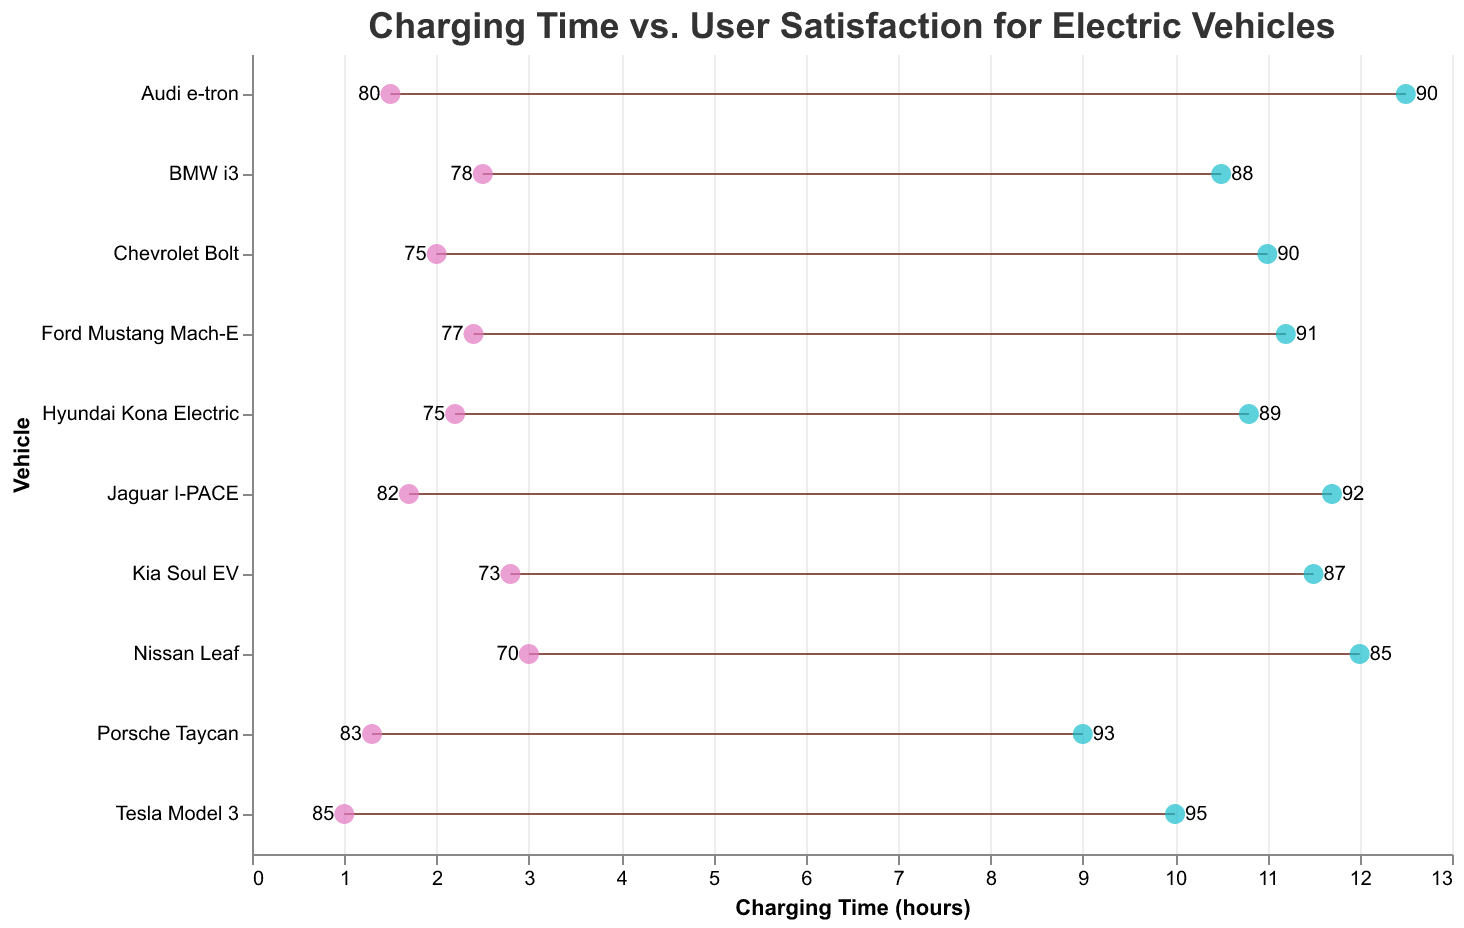What is the minimum charging time for the Tesla Model 3? The Tesla Model 3 has a minimum charging time indicated by the leftmost point of the dumbbell plot for that vehicle.
Answer: 1 hour Which vehicle has the highest maximum user satisfaction rating? The maximum user satisfaction rating is indicated by the number on the rightmost side of each dumbbell plot. The Tesla Model 3 has a maximum rating of 95, which is higher than any other vehicle.
Answer: Tesla Model 3 What is the average maximum charging time across all vehicles? To find the average maximum charging time, add up all the maximum charging times for each vehicle: (10 + 12 + 11 + 10.5 + 12.5 + 11.7 + 10.8 + 11.5 + 9 + 11.2) = 110.2. Then, divide by the number of vehicles (10): 110.2 / 10 = 11.02.
Answer: 11.02 hours Which vehicle shows the smallest range in charging time? The range in charging time is the difference between the maximum and minimum charging times for each vehicle. Tesla Model 3: 10 - 1 = 9, Nissan Leaf: 12 - 3 = 9, Chevrolet Bolt: 11 - 2 = 9, BMW i3: 10.5 - 2.5 = 8, Audi e-tron: 12.5 - 1.5 = 11, Jaguar I-PACE: 11.7 - 1.7 = 10, Hyundai Kona Electric: 10.8 - 2.2 = 8.6, Kia Soul EV: 11.5 - 2.8 = 8.7, Porsche Taycan: 9 - 1.3 = 7.7, Ford Mustang Mach-E: 11.2 - 2.4 = 8.8. Therefore, Porsche Taycan shows the smallest range of 7.7 hours.
Answer: Porsche Taycan For which vehicle is the user satisfaction rating range the largest? The range in user satisfaction rating is the difference between maximum and minimum user satisfaction ratings. Tesla Model 3: 95 - 85 = 10, Nissan Leaf: 85 - 70 = 15, Chevrolet Bolt: 90 - 75 = 15, BMW i3: 88 - 78 = 10, Audi e-tron: 90 - 80 = 10, Jaguar I-PACE: 92 - 82 = 10, Hyundai Kona Electric: 89 - 75 = 14, Kia Soul EV: 87 - 73 = 14, Porsche Taycan: 93 - 83 = 10, Ford Mustang Mach-E: 91 - 77 = 14. Therefore, Chevrolet Bolt and Nissan Leaf have the largest user satisfaction rating range of 15.
Answer: Chevrolet Bolt and Nissan Leaf Which vehicle has the shortest maximum charging time and what is it? The shortest maximum charging time is indicated by the rightmost points of the dumbbell plots. The Porsche Taycan has the shortest maximum charging time of 9 hours.
Answer: Porsche Taycan with 9 hours What is the difference in minimum charging time between the Jaguar I-PACE and the Audi e-tron? The minimum charging time for the Jaguar I-PACE is 1.7 hours and for the Audi e-tron is 1.5 hours. The difference is 1.7 - 1.5 = 0.2 hours.
Answer: 0.2 hours Which vehicle has the highest minimum user satisfaction rating and what is it? The highest minimum user satisfaction rating is indicated by the number on the leftmost side of each vehicle’s dumbbell plot. The Tesla Model 3 has the highest minimum user satisfaction rating of 85.
Answer: Tesla Model 3 with 85 Is there any vehicle that takes longer than 12 hours to charge at its maximum? According to the rightmost points of the dumbbell plots, the Audi e-tron and Nissan Leaf both take longer than 12 hours to charge at their maximum charging times.
Answer: Yes, Audi e-tron and Nissan Leaf 